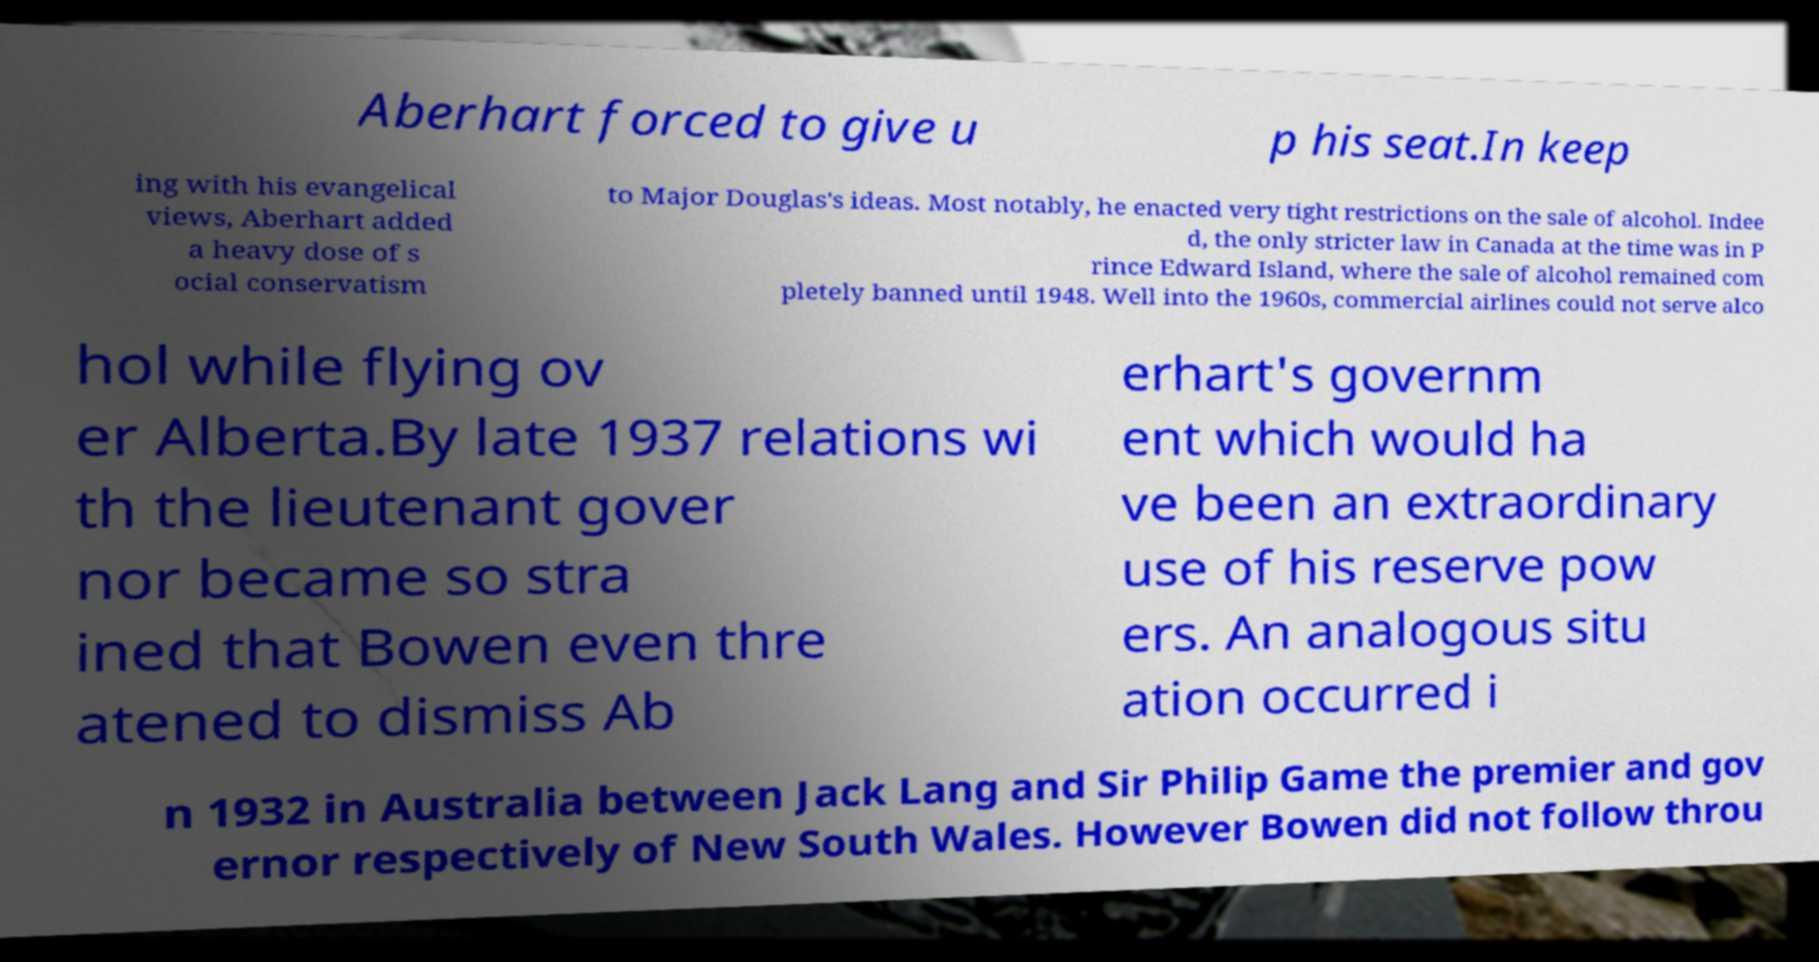There's text embedded in this image that I need extracted. Can you transcribe it verbatim? Aberhart forced to give u p his seat.In keep ing with his evangelical views, Aberhart added a heavy dose of s ocial conservatism to Major Douglas's ideas. Most notably, he enacted very tight restrictions on the sale of alcohol. Indee d, the only stricter law in Canada at the time was in P rince Edward Island, where the sale of alcohol remained com pletely banned until 1948. Well into the 1960s, commercial airlines could not serve alco hol while flying ov er Alberta.By late 1937 relations wi th the lieutenant gover nor became so stra ined that Bowen even thre atened to dismiss Ab erhart's governm ent which would ha ve been an extraordinary use of his reserve pow ers. An analogous situ ation occurred i n 1932 in Australia between Jack Lang and Sir Philip Game the premier and gov ernor respectively of New South Wales. However Bowen did not follow throu 